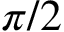<formula> <loc_0><loc_0><loc_500><loc_500>\pi / 2</formula> 